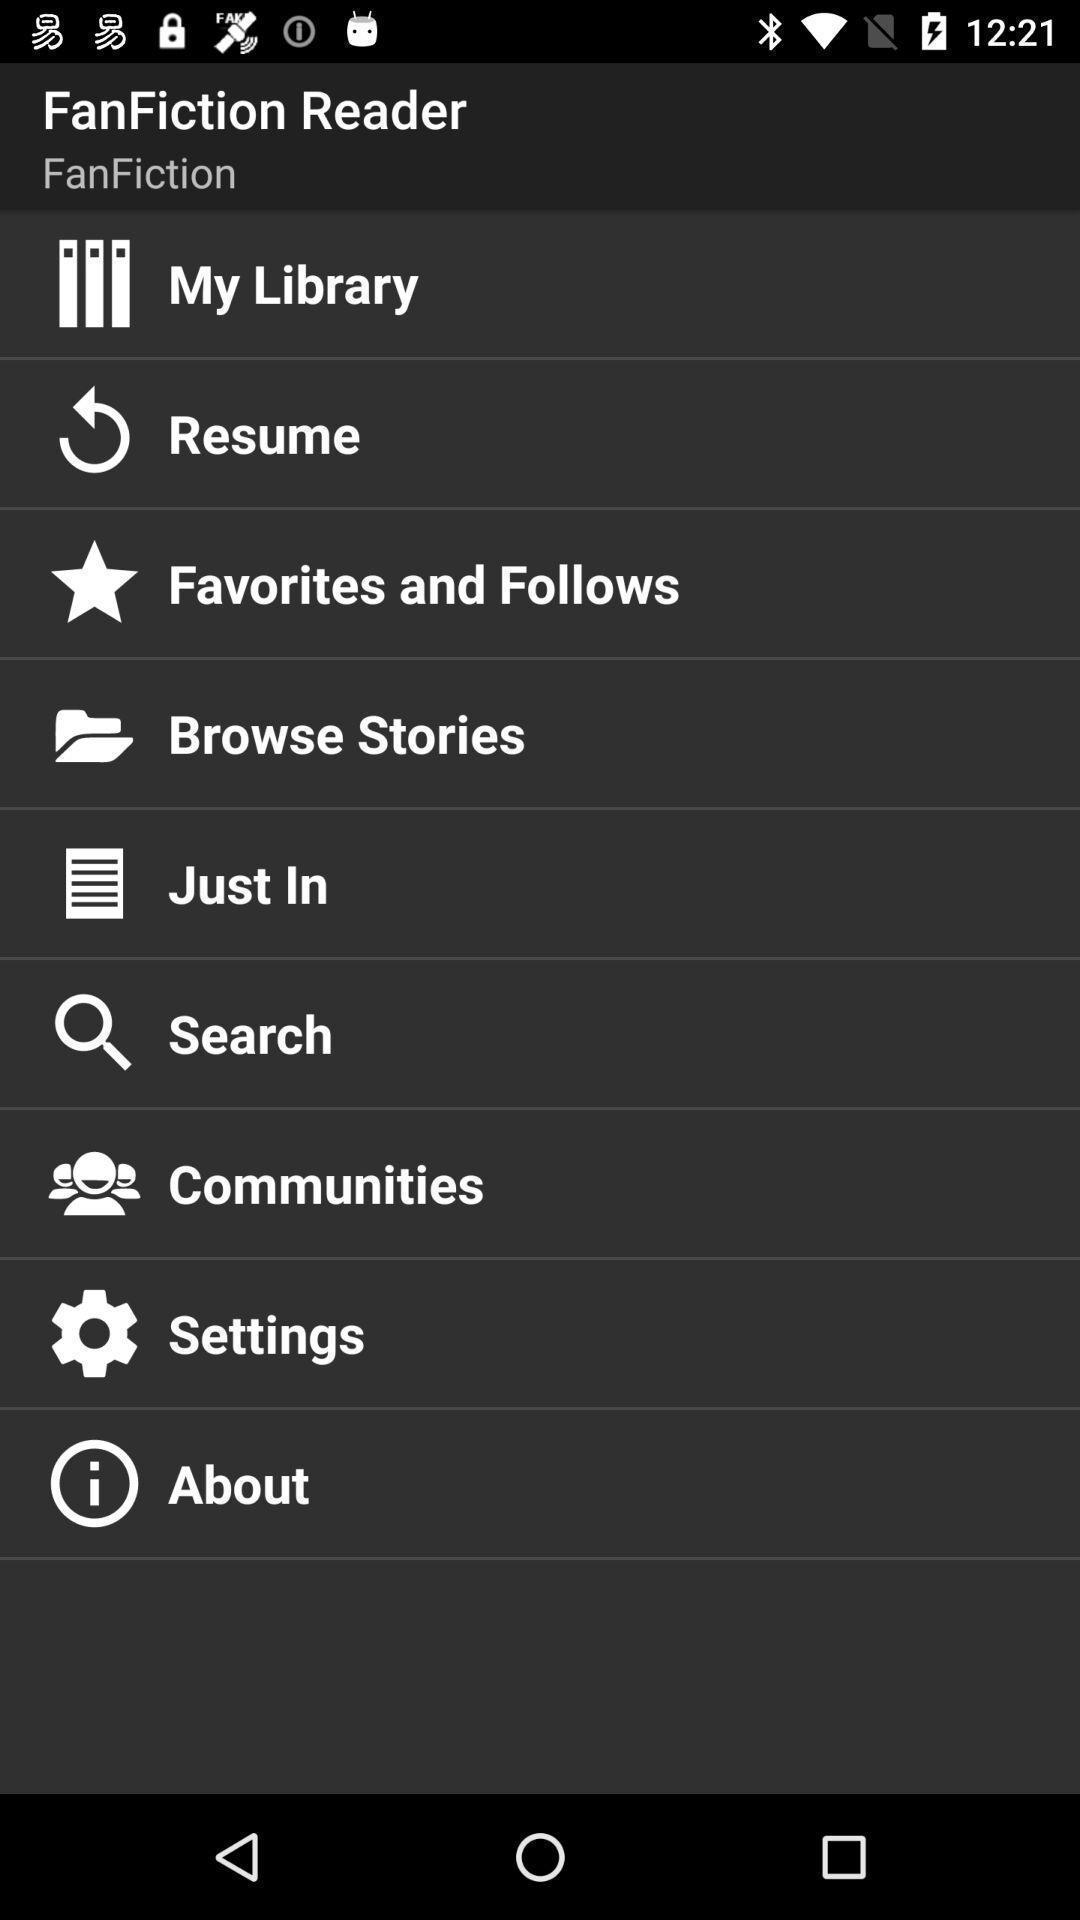Explain what's happening in this screen capture. Page showing list of menu options on an app. 